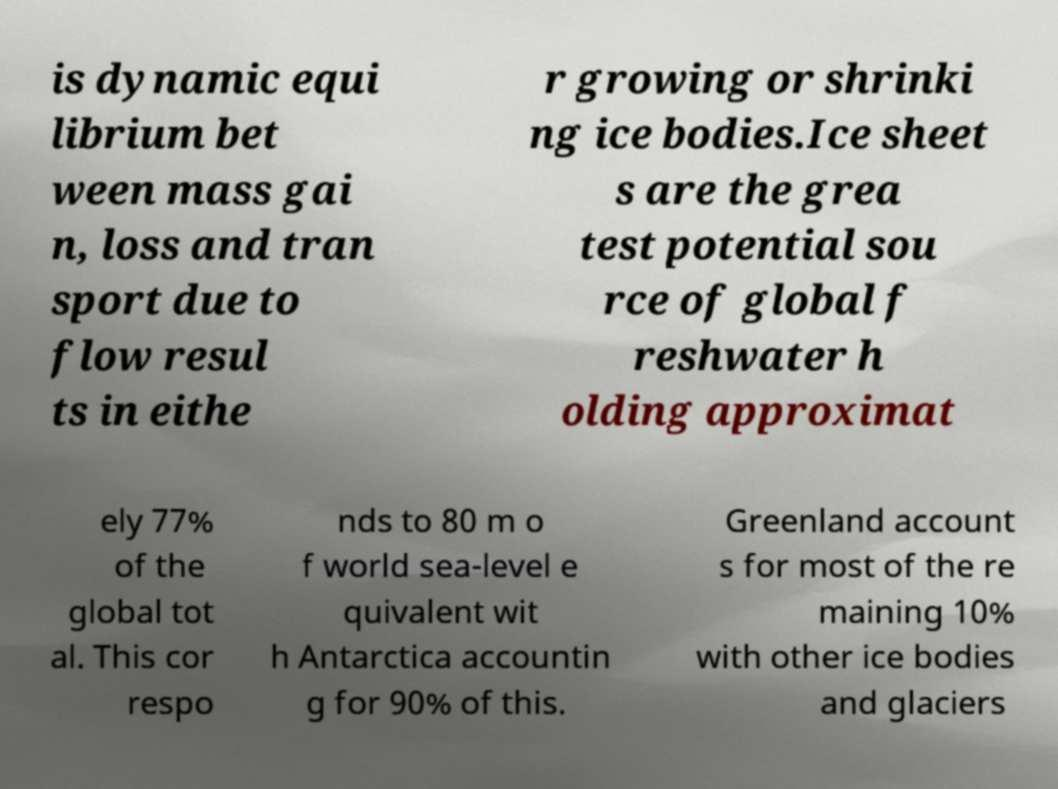For documentation purposes, I need the text within this image transcribed. Could you provide that? is dynamic equi librium bet ween mass gai n, loss and tran sport due to flow resul ts in eithe r growing or shrinki ng ice bodies.Ice sheet s are the grea test potential sou rce of global f reshwater h olding approximat ely 77% of the global tot al. This cor respo nds to 80 m o f world sea-level e quivalent wit h Antarctica accountin g for 90% of this. Greenland account s for most of the re maining 10% with other ice bodies and glaciers 